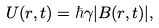Convert formula to latex. <formula><loc_0><loc_0><loc_500><loc_500>U ( { r } , t ) = \hbar { \gamma } | { B } ( { r } , t ) | ,</formula> 